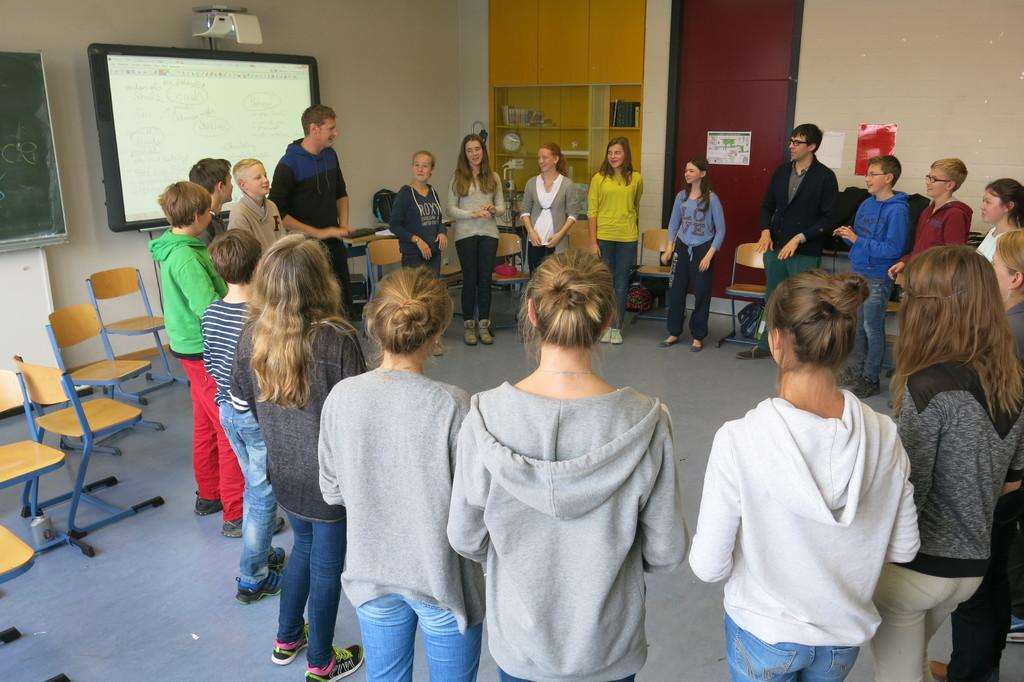What can be seen in the image regarding people? There are people standing in the image. Where are the people standing? The people are standing on the floor. What can be seen in the image related to a visual display? There is a projector in the image, and it is displaying an image. What is present in the image for seating purposes? There are chairs in the image. What is being used to store objects in the image? There are objects in a cupboard. What is present in the image that might be used for carrying belongings? There are bags in the image. What can be seen in the image related to decoration or visual interest? There are pictures pasted on the walls. Can you describe the mountain visible in the image? There is no mountain present in the image. What type of force is being applied to the people in the image? There is no force being applied to the people in the image; they are standing on the floor. 